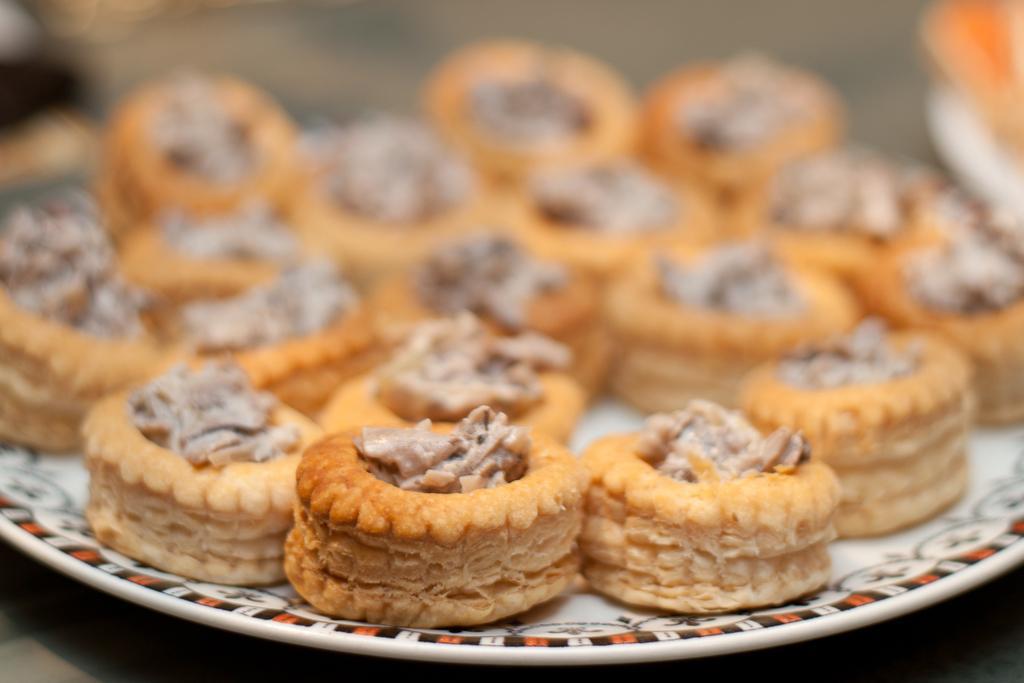Please provide a concise description of this image. In this image we can see some food items on the plate, and the background is blurred. 